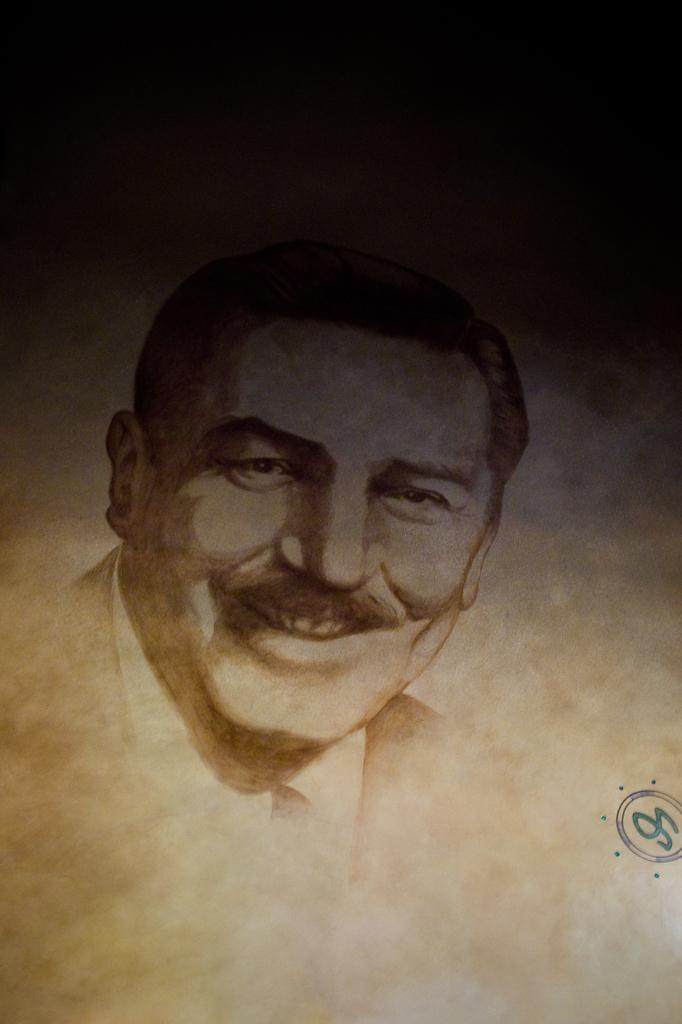What is depicted in the painting in the image? There is a painting of a person in the image. What else can be seen in the image besides the painting? There is a logo in the image. What type of cheese is on the plate next to the painting? There is no plate or cheese present in the image; it only features a painting and a logo. 